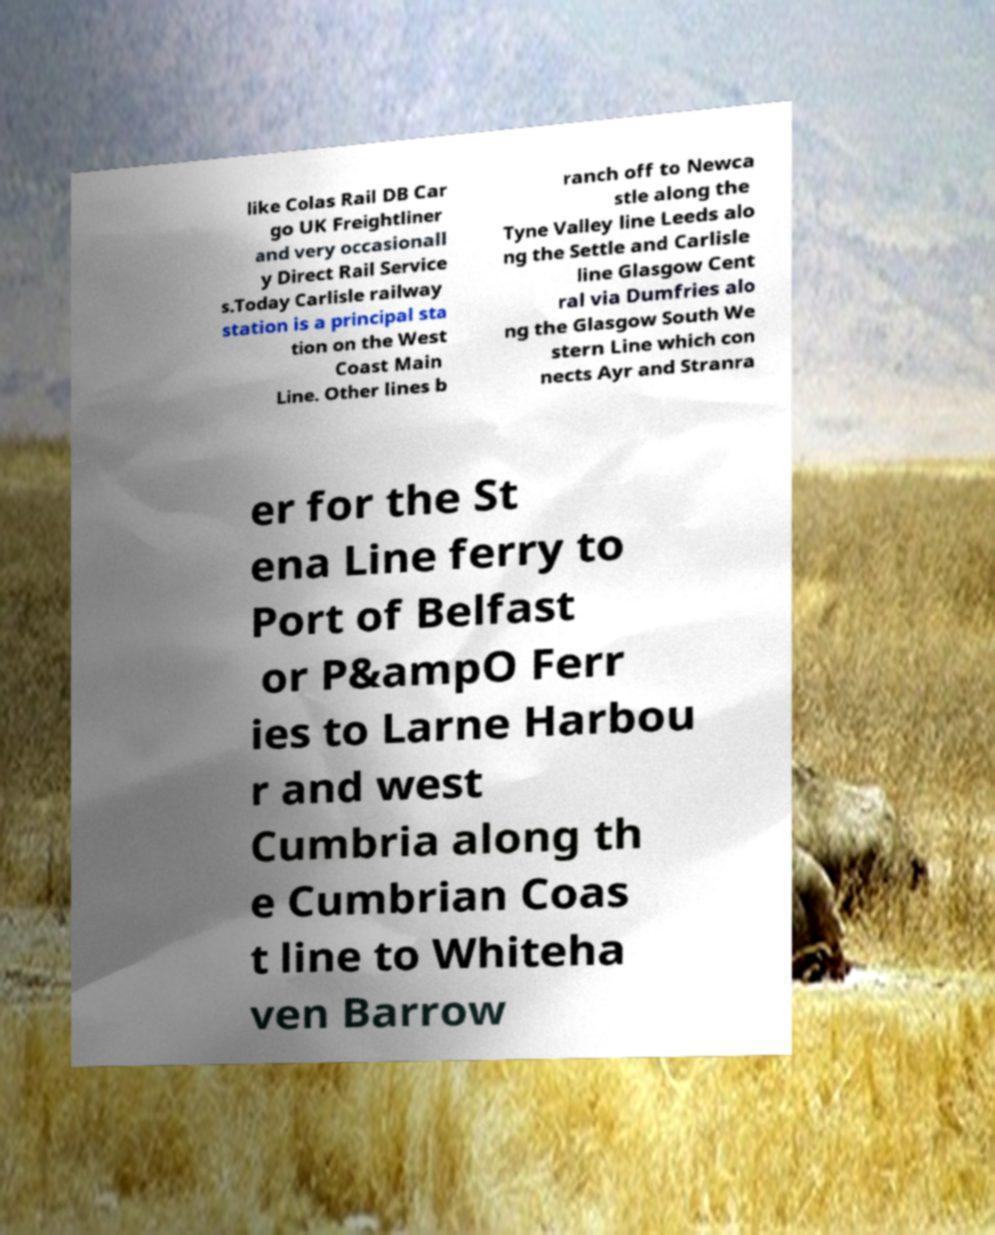Could you assist in decoding the text presented in this image and type it out clearly? like Colas Rail DB Car go UK Freightliner and very occasionall y Direct Rail Service s.Today Carlisle railway station is a principal sta tion on the West Coast Main Line. Other lines b ranch off to Newca stle along the Tyne Valley line Leeds alo ng the Settle and Carlisle line Glasgow Cent ral via Dumfries alo ng the Glasgow South We stern Line which con nects Ayr and Stranra er for the St ena Line ferry to Port of Belfast or P&ampO Ferr ies to Larne Harbou r and west Cumbria along th e Cumbrian Coas t line to Whiteha ven Barrow 